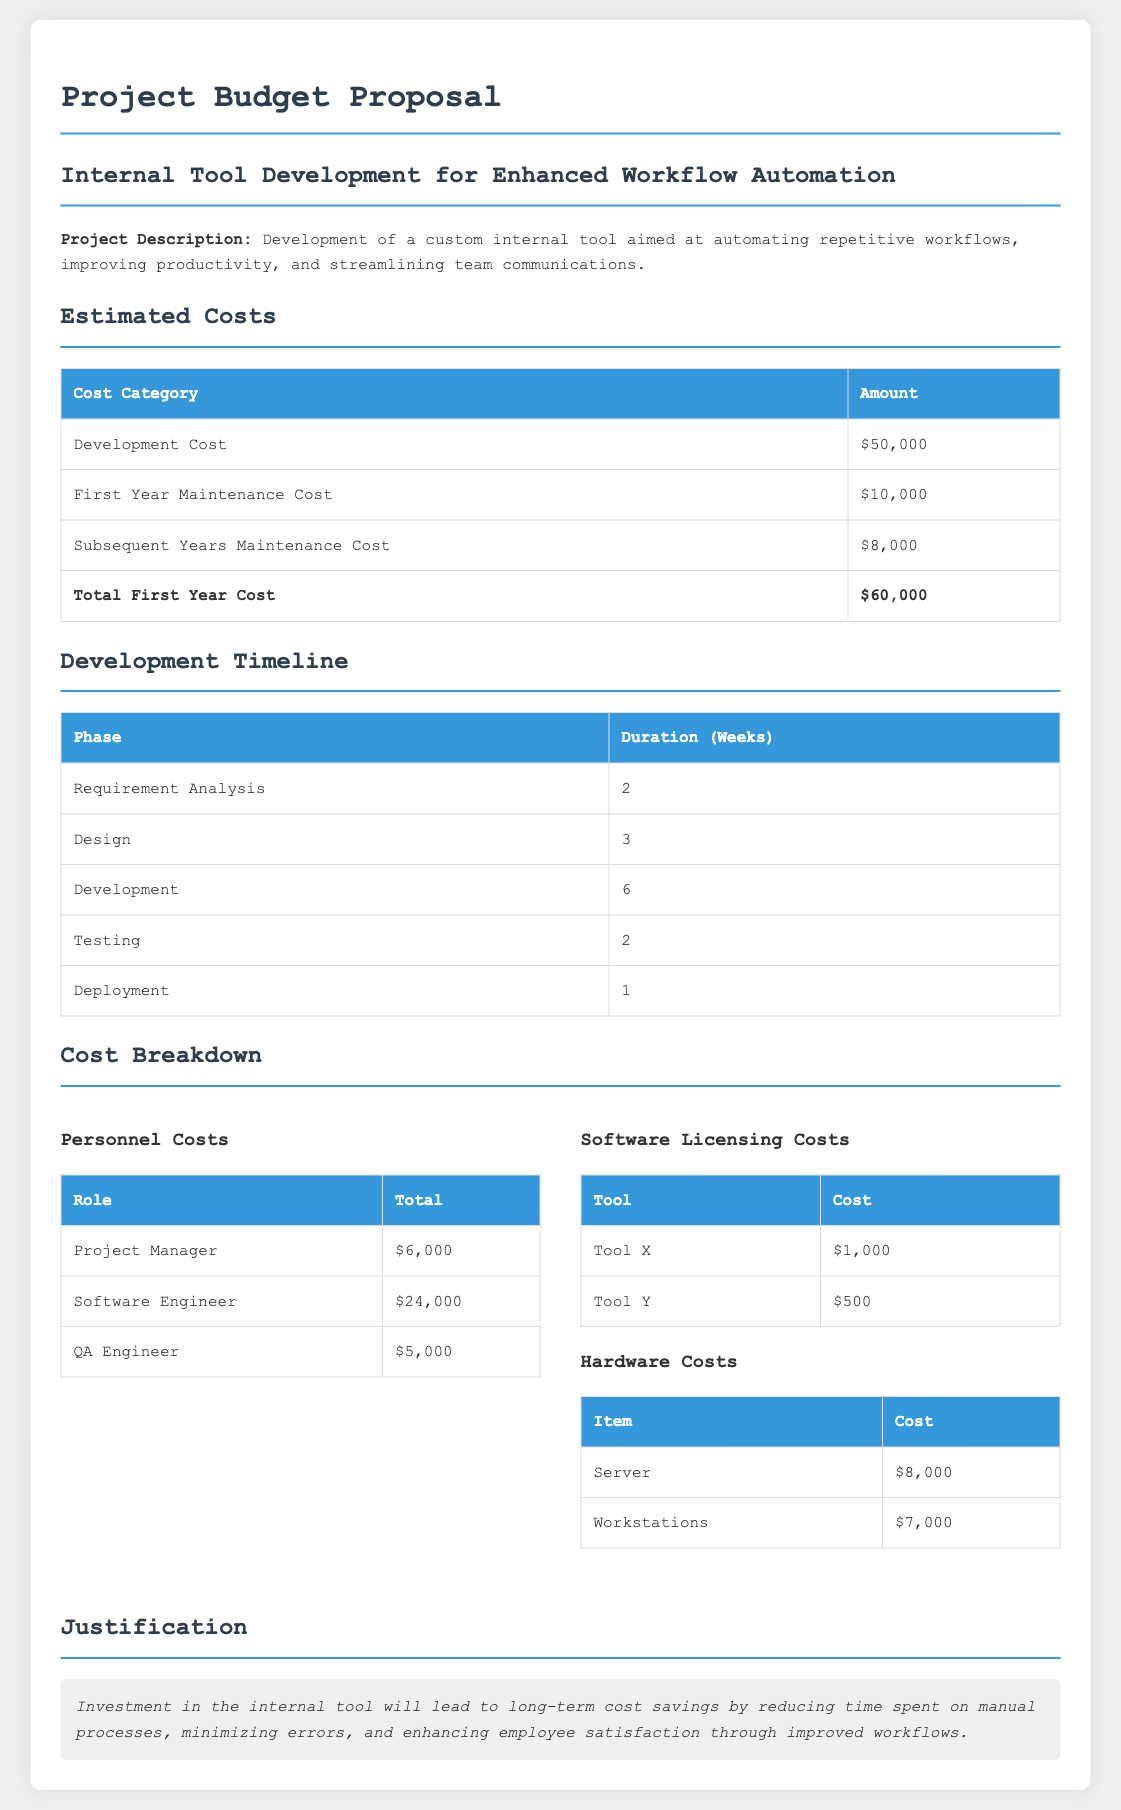What is the total development cost? The total development cost is listed as $50,000 in the document.
Answer: $50,000 What is the first year maintenance cost? The first year maintenance cost is explicitly stated in the document as $10,000.
Answer: $10,000 How many weeks is the testing phase? The document specifies that the testing phase has a duration of 2 weeks.
Answer: 2 What is the total first year cost? The total first year cost is calculated as development cost plus first year maintenance cost, which is $60,000.
Answer: $60,000 How much is allocated for the Project Manager? The document notes that $6,000 is allocated for the Project Manager's costs.
Answer: $6,000 What are the hardware costs for Workstations? The cost allocation for Workstations in the document is $7,000.
Answer: $7,000 What is the total cost for Tool X and Tool Y? The combined cost for Tool X ($1,000) and Tool Y ($500) is calculated as $1,500.
Answer: $1,500 What is the rationale for investing in the internal tool? The justification presented states that investment will lead to long-term cost savings and improved workflows.
Answer: long-term cost savings and improved workflows How many phases are there in the development timeline? The document lays out a total of 5 phases in the development timeline.
Answer: 5 What is the total cost for the QA Engineer? The document specifies that $5,000 is allocated for the QA Engineer's costs.
Answer: $5,000 